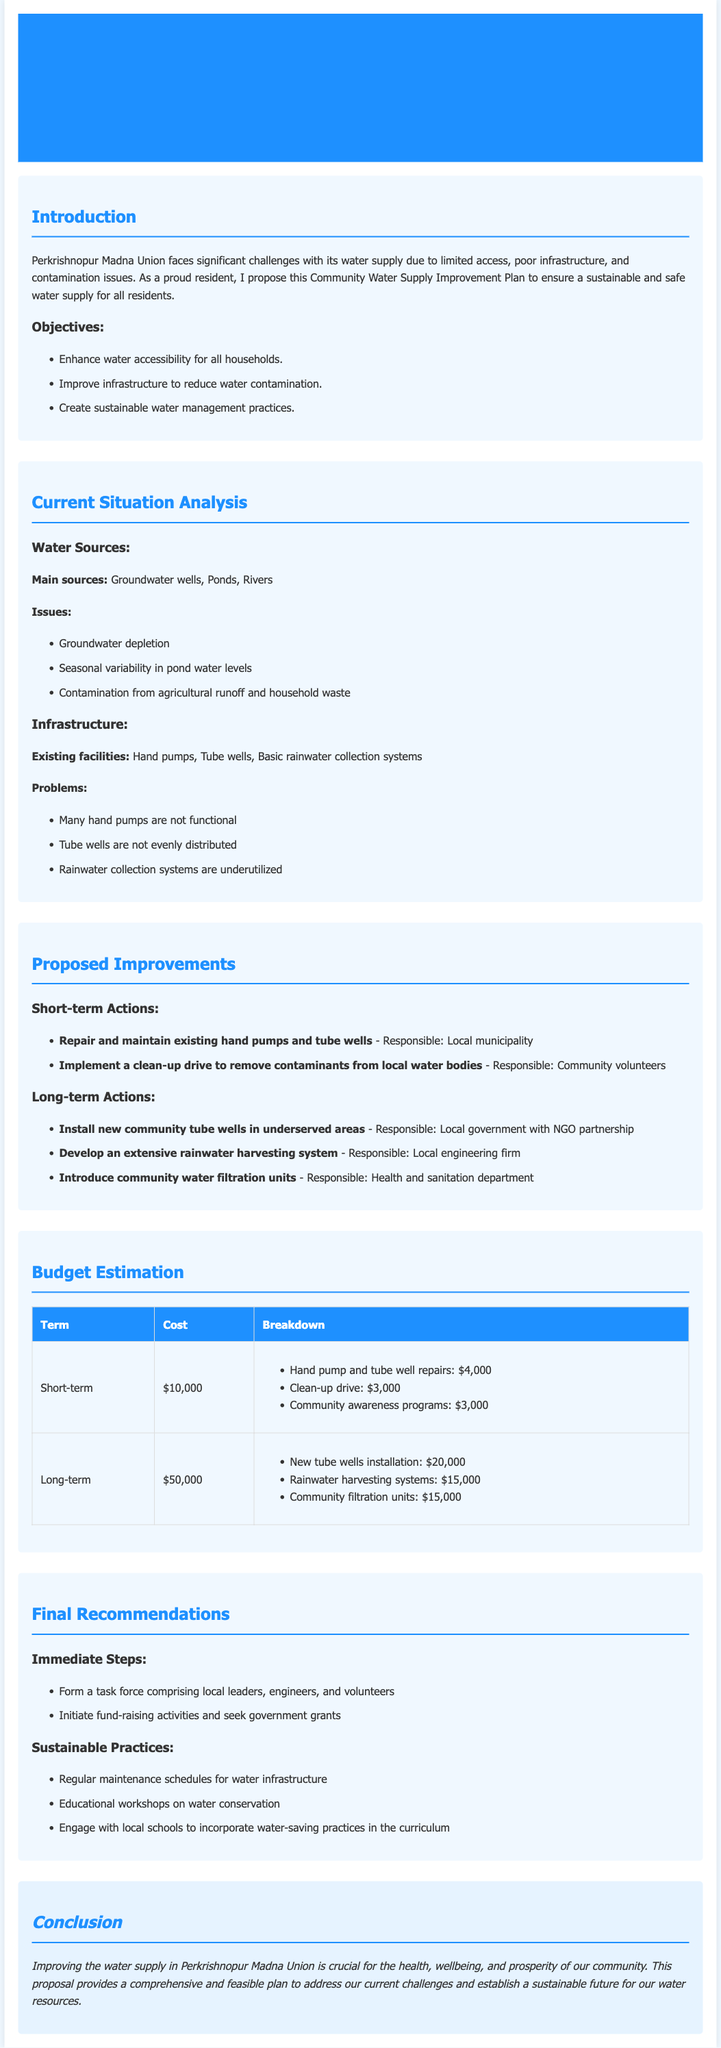What are the main water sources? The document lists the main water sources as groundwater wells, ponds, and rivers.
Answer: Groundwater wells, Ponds, Rivers What is the total cost for short-term actions? The total cost for short-term actions is indicated as $10,000 in the budget estimation section.
Answer: $10,000 Who is responsible for implementing the clean-up drive? The responsibility for the clean-up drive is assigned to community volunteers as per the proposed actions.
Answer: Community volunteers What issue is caused by agricultural runoff? The document mentions contamination from agricultural runoff as one of the issues affecting water sources.
Answer: Contamination What is a proposed immediate step? An immediate step proposed in the document is forming a task force comprising local leaders, engineers, and volunteers.
Answer: Form a task force Which entity will install new community tube wells? The document states that the local government, in partnership with NGOs, will be responsible for installing new community tube wells.
Answer: Local government with NGO partnership How much is allocated for the installation of new tube wells? The budget estimation specifies that $20,000 is allocated for the installation of new tube wells.
Answer: $20,000 What is the goal of the proposed educational workshops? The goal of the proposed educational workshops is on water conservation as suggested in the sustainable practices section.
Answer: Water conservation 